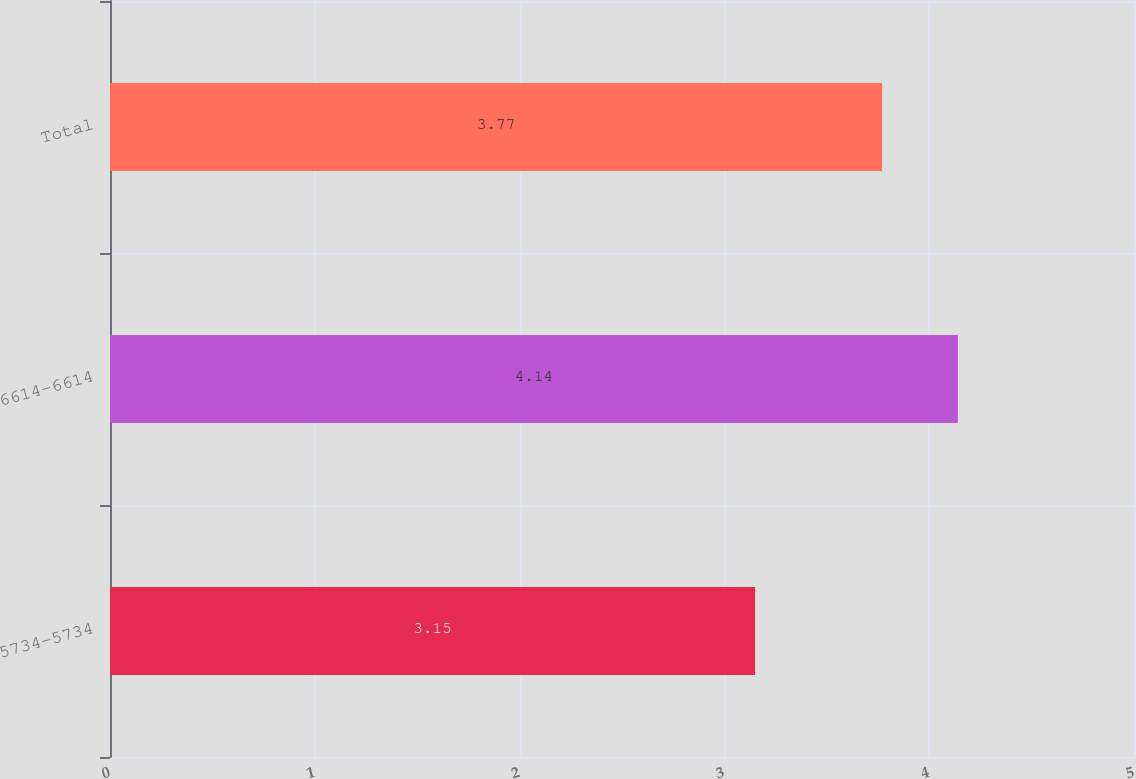Convert chart to OTSL. <chart><loc_0><loc_0><loc_500><loc_500><bar_chart><fcel>5734-5734<fcel>6614-6614<fcel>Total<nl><fcel>3.15<fcel>4.14<fcel>3.77<nl></chart> 